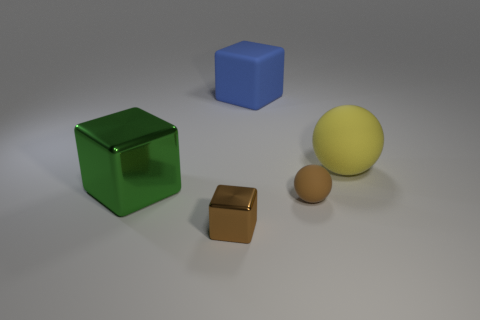Are any yellow rubber things visible?
Your answer should be compact. Yes. There is a small thing that is right of the metallic thing that is in front of the metallic block that is behind the brown ball; what color is it?
Offer a very short reply. Brown. Are there the same number of rubber blocks on the left side of the big green shiny thing and big green metallic objects in front of the tiny brown cube?
Your response must be concise. Yes. What shape is the yellow rubber thing that is the same size as the blue cube?
Make the answer very short. Sphere. Are there any large matte things that have the same color as the small rubber ball?
Provide a succinct answer. No. The tiny brown object to the right of the brown metallic object has what shape?
Provide a short and direct response. Sphere. What color is the small matte ball?
Keep it short and to the point. Brown. What is the color of the other object that is the same material as the large green thing?
Ensure brevity in your answer.  Brown. How many other big things are made of the same material as the big blue thing?
Provide a succinct answer. 1. What number of spheres are right of the tiny matte sphere?
Keep it short and to the point. 1. 